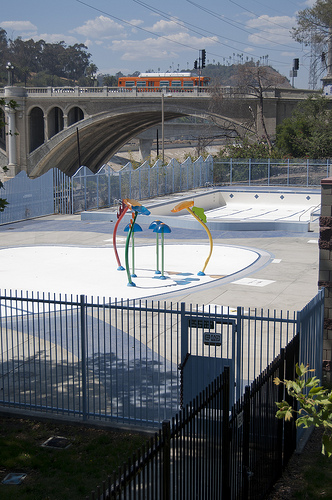<image>
Is the bridge to the right of the swimming pool? No. The bridge is not to the right of the swimming pool. The horizontal positioning shows a different relationship. Is the pool in the gate? No. The pool is not contained within the gate. These objects have a different spatial relationship. 